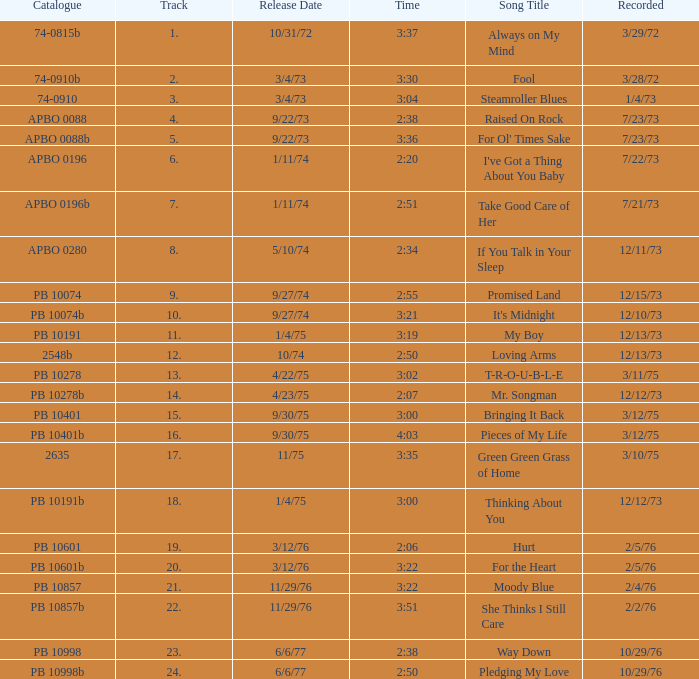I want the sum of tracks for raised on rock 4.0. 